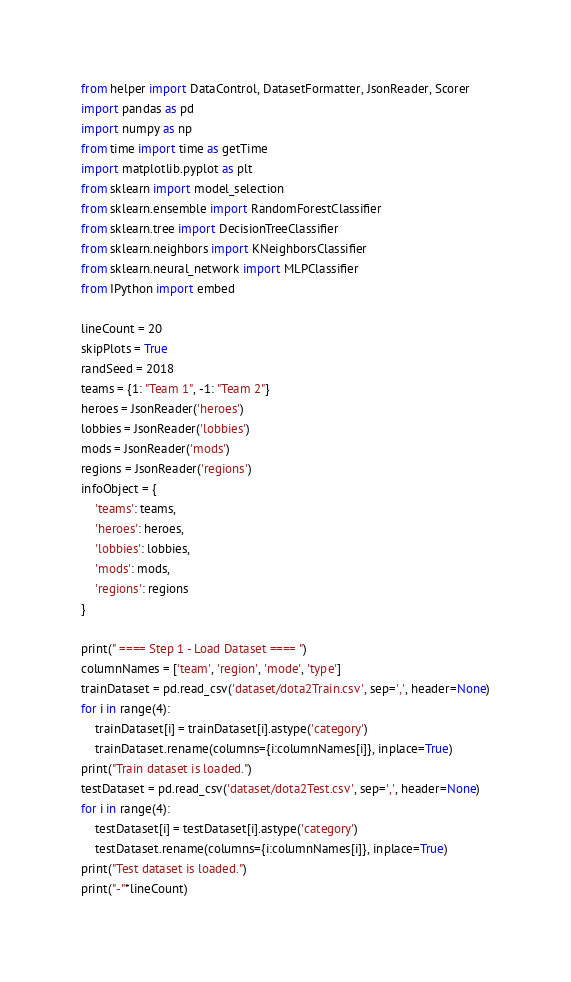<code> <loc_0><loc_0><loc_500><loc_500><_Python_>from helper import DataControl, DatasetFormatter, JsonReader, Scorer
import pandas as pd
import numpy as np
from time import time as getTime
import matplotlib.pyplot as plt
from sklearn import model_selection
from sklearn.ensemble import RandomForestClassifier
from sklearn.tree import DecisionTreeClassifier
from sklearn.neighbors import KNeighborsClassifier
from sklearn.neural_network import MLPClassifier
from IPython import embed

lineCount = 20
skipPlots = True
randSeed = 2018
teams = {1: "Team 1", -1: "Team 2"}
heroes = JsonReader('heroes')
lobbies = JsonReader('lobbies')
mods = JsonReader('mods')
regions = JsonReader('regions')
infoObject = {
    'teams': teams,
    'heroes': heroes,
    'lobbies': lobbies,
    'mods': mods,
    'regions': regions
}

print(" ==== Step 1 - Load Dataset ==== ")
columnNames = ['team', 'region', 'mode', 'type']
trainDataset = pd.read_csv('dataset/dota2Train.csv', sep=',', header=None)
for i in range(4):
    trainDataset[i] = trainDataset[i].astype('category')
    trainDataset.rename(columns={i:columnNames[i]}, inplace=True)
print("Train dataset is loaded.")
testDataset = pd.read_csv('dataset/dota2Test.csv', sep=',', header=None)
for i in range(4):
    testDataset[i] = testDataset[i].astype('category')
    testDataset.rename(columns={i:columnNames[i]}, inplace=True)
print("Test dataset is loaded.")
print("-"*lineCount)
</code> 